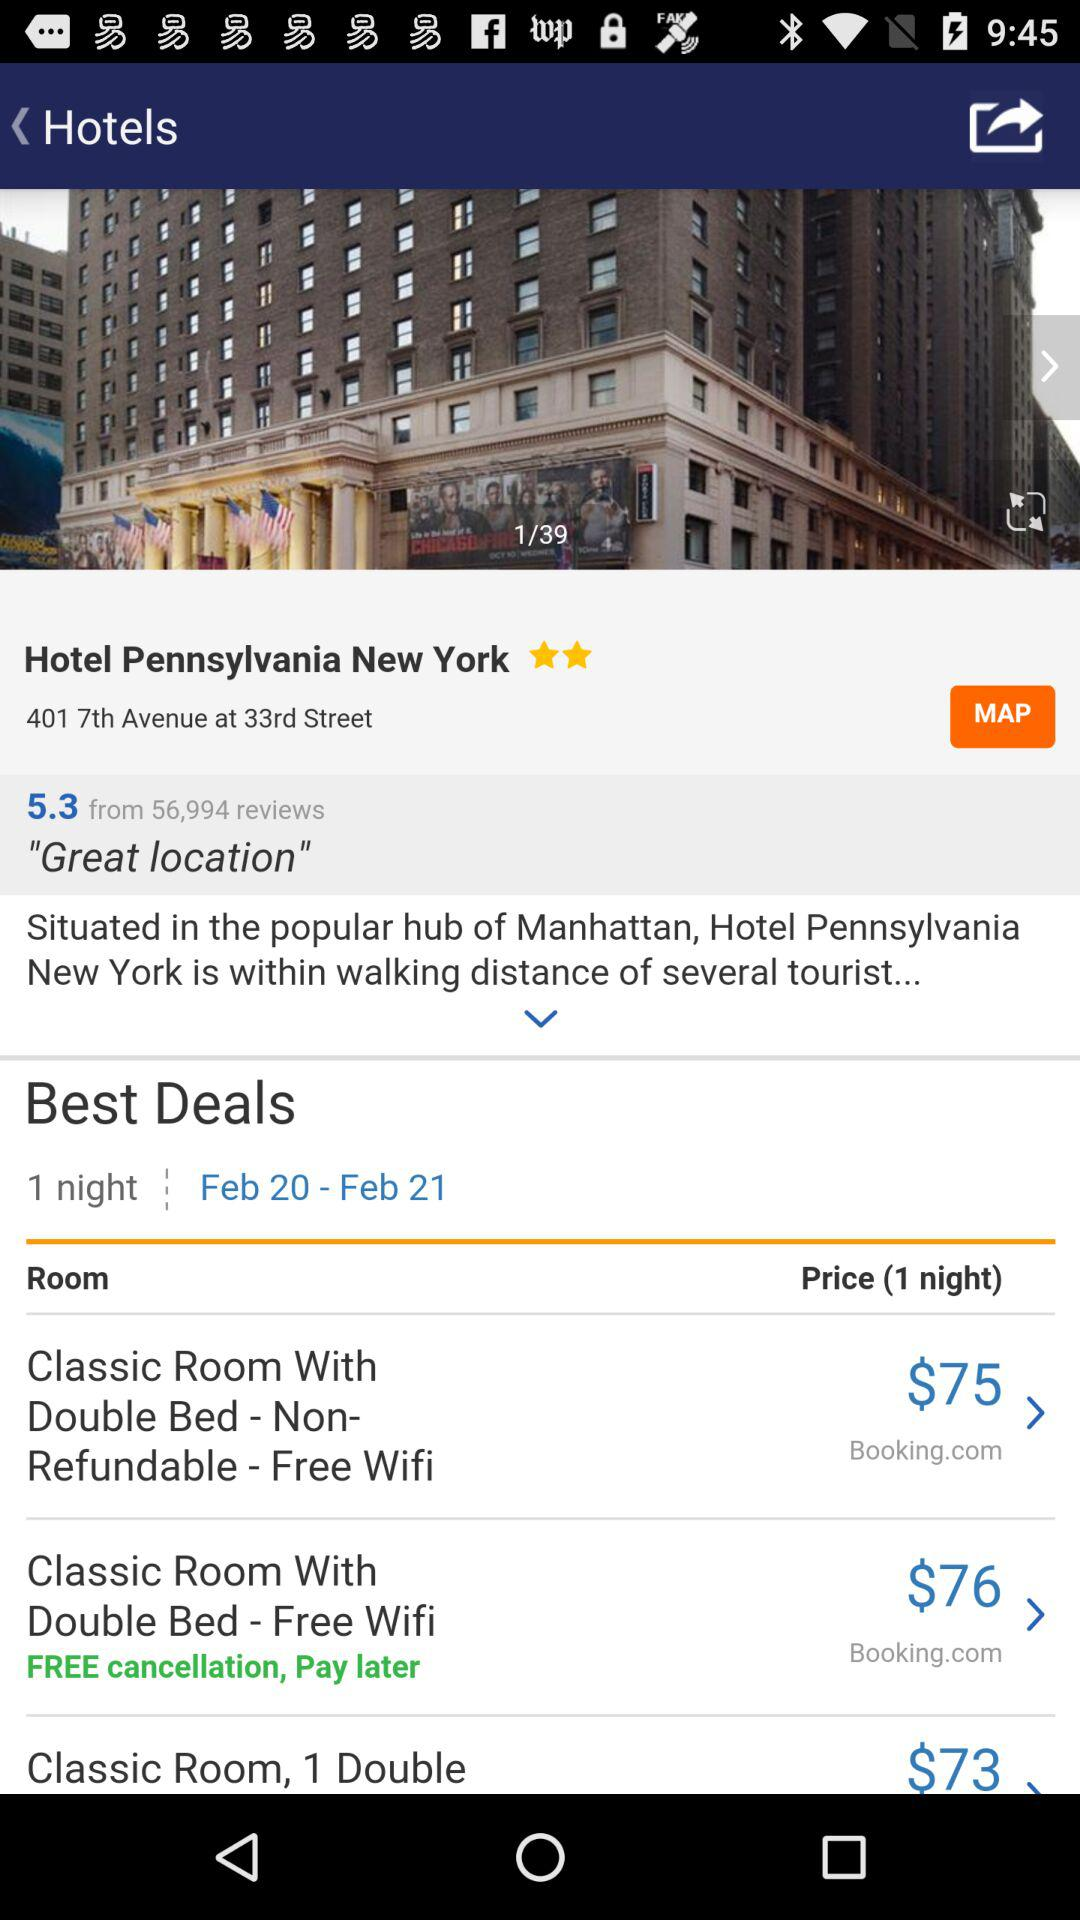What is the price for a classic room with a double bed for one night? The price for a classic room with a double bed for one night is $75. 